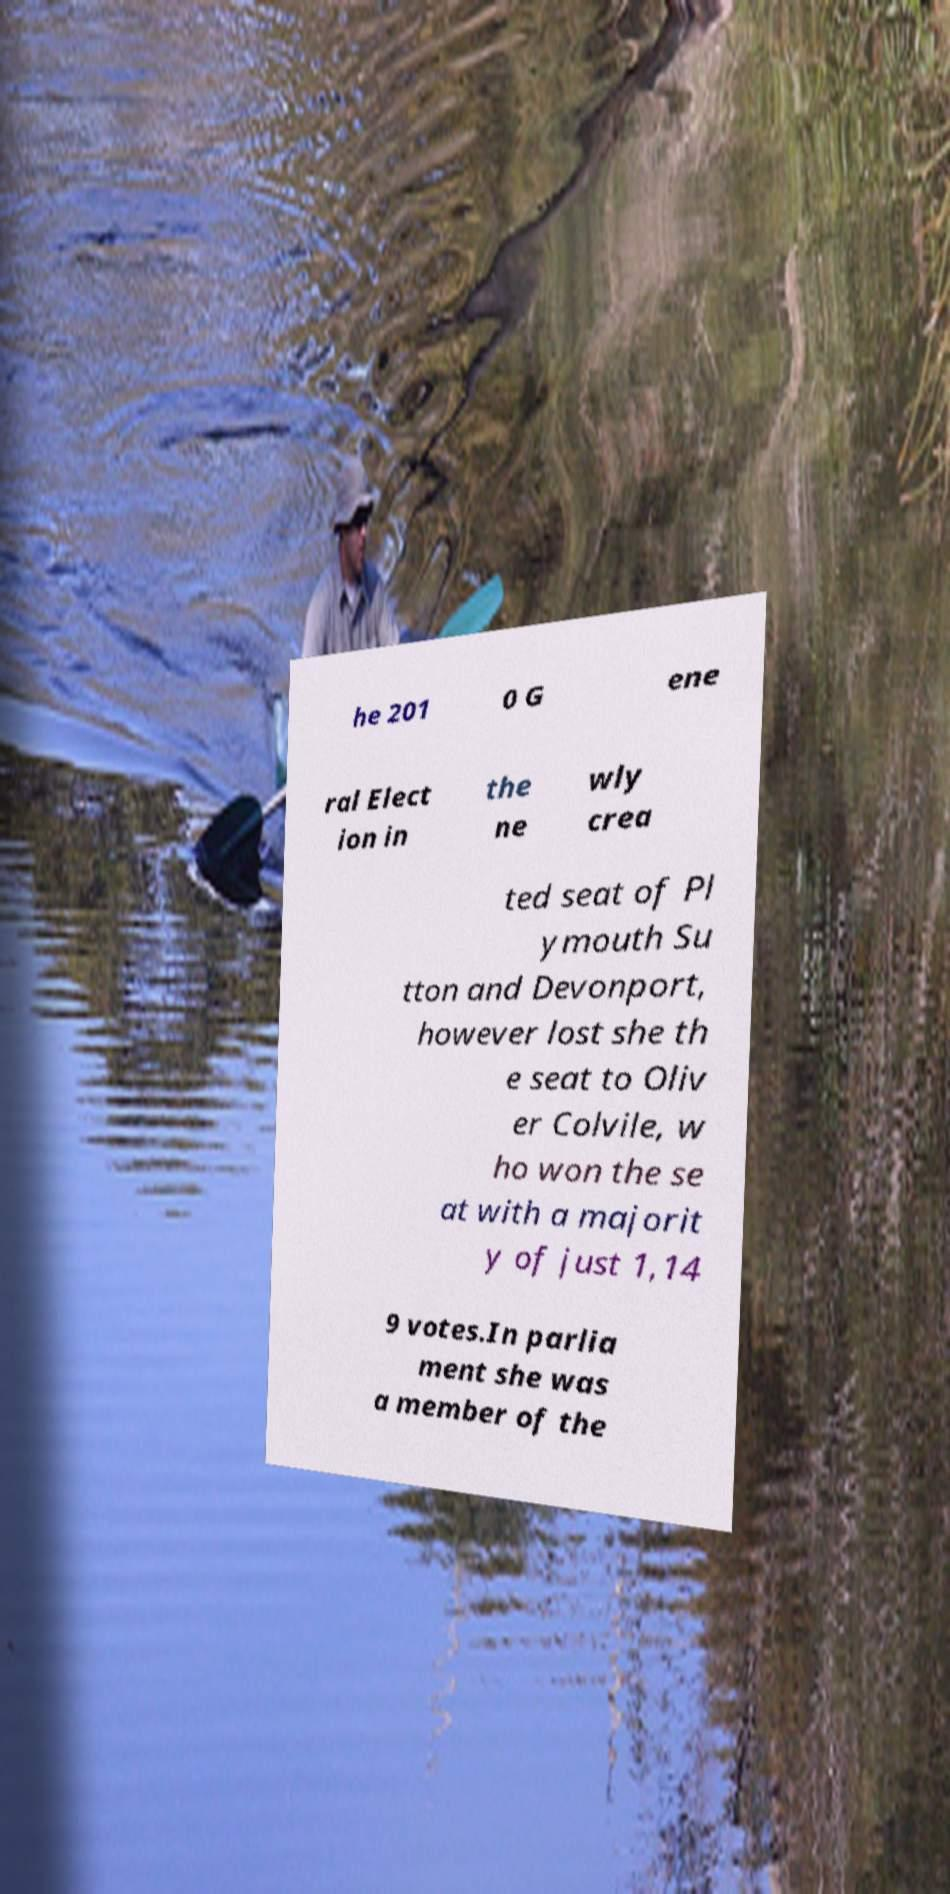Could you assist in decoding the text presented in this image and type it out clearly? he 201 0 G ene ral Elect ion in the ne wly crea ted seat of Pl ymouth Su tton and Devonport, however lost she th e seat to Oliv er Colvile, w ho won the se at with a majorit y of just 1,14 9 votes.In parlia ment she was a member of the 